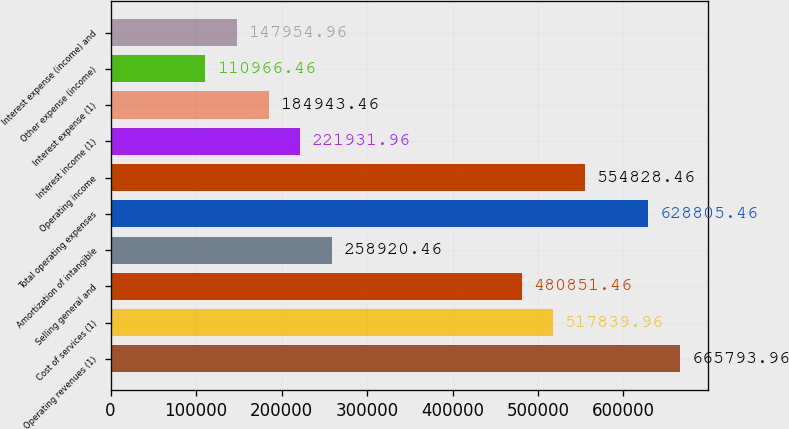Convert chart to OTSL. <chart><loc_0><loc_0><loc_500><loc_500><bar_chart><fcel>Operating revenues (1)<fcel>Cost of services (1)<fcel>Selling general and<fcel>Amortization of intangible<fcel>Total operating expenses<fcel>Operating income<fcel>Interest income (1)<fcel>Interest expense (1)<fcel>Other expense (income)<fcel>Interest expense (income) and<nl><fcel>665794<fcel>517840<fcel>480851<fcel>258920<fcel>628805<fcel>554828<fcel>221932<fcel>184943<fcel>110966<fcel>147955<nl></chart> 